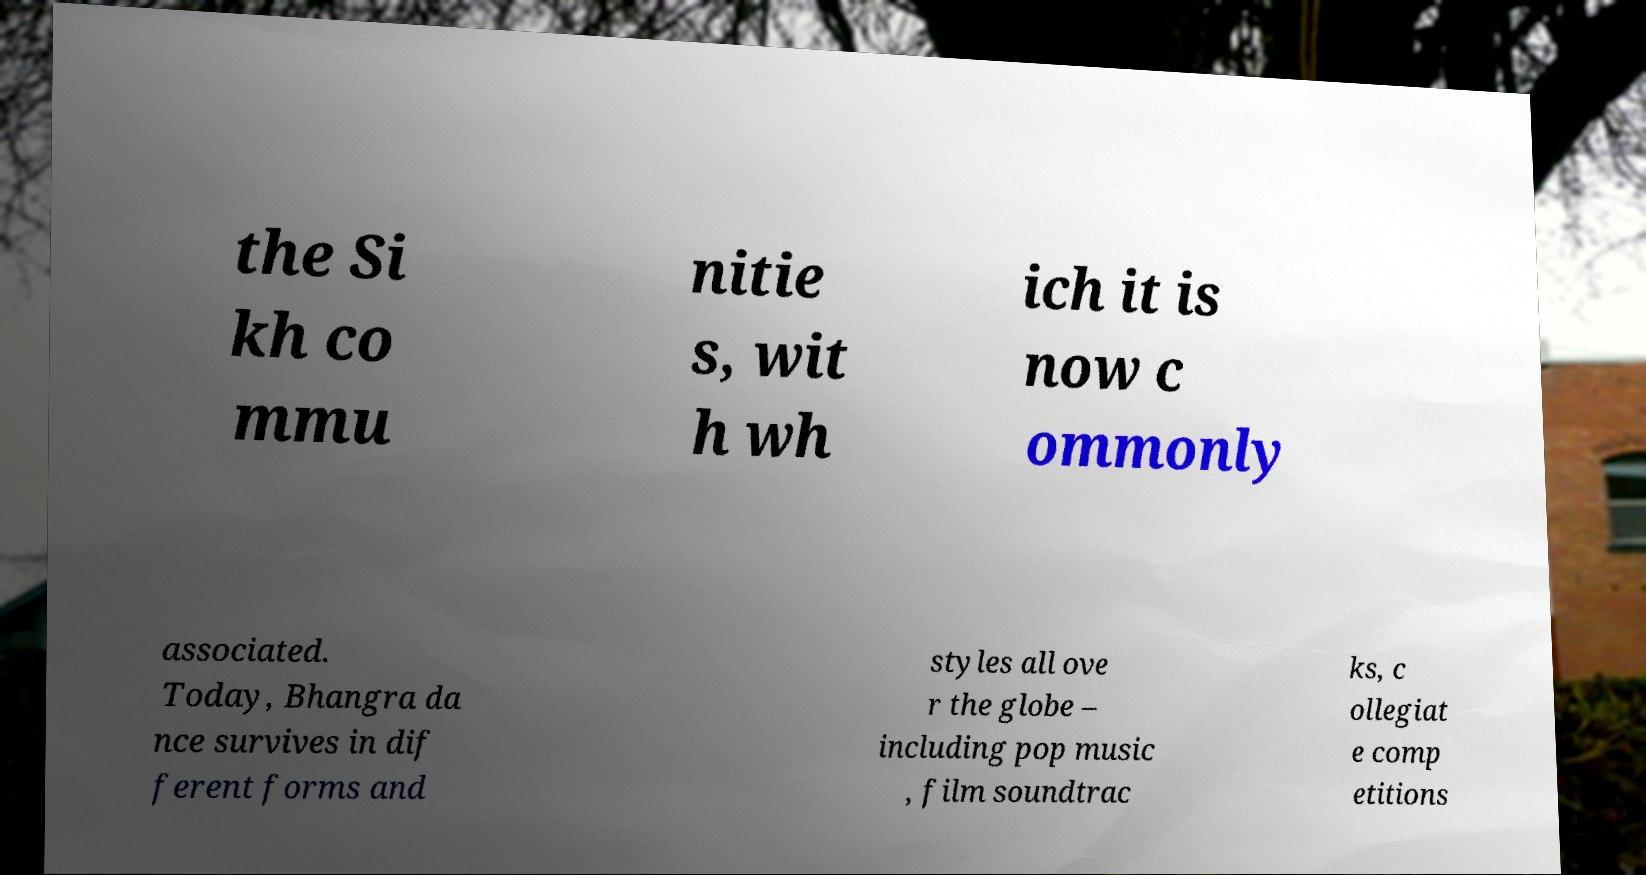I need the written content from this picture converted into text. Can you do that? the Si kh co mmu nitie s, wit h wh ich it is now c ommonly associated. Today, Bhangra da nce survives in dif ferent forms and styles all ove r the globe – including pop music , film soundtrac ks, c ollegiat e comp etitions 